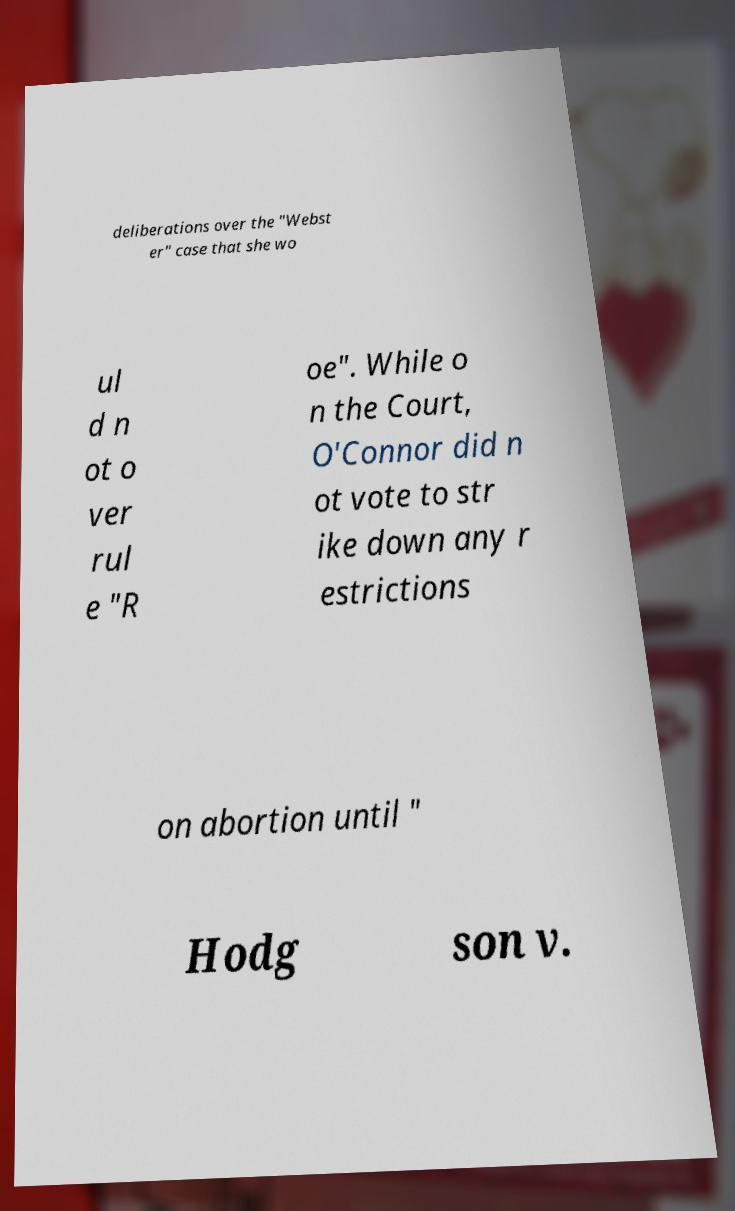For documentation purposes, I need the text within this image transcribed. Could you provide that? deliberations over the "Webst er" case that she wo ul d n ot o ver rul e "R oe". While o n the Court, O'Connor did n ot vote to str ike down any r estrictions on abortion until " Hodg son v. 